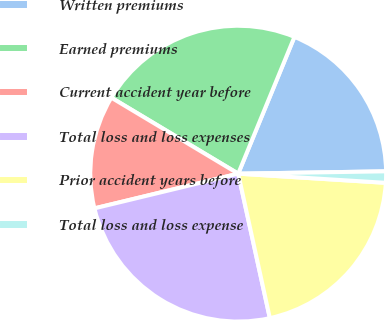<chart> <loc_0><loc_0><loc_500><loc_500><pie_chart><fcel>Written premiums<fcel>Earned premiums<fcel>Current accident year before<fcel>Total loss and loss expenses<fcel>Prior accident years before<fcel>Total loss and loss expense<nl><fcel>18.54%<fcel>22.62%<fcel>12.36%<fcel>24.66%<fcel>20.58%<fcel>1.24%<nl></chart> 